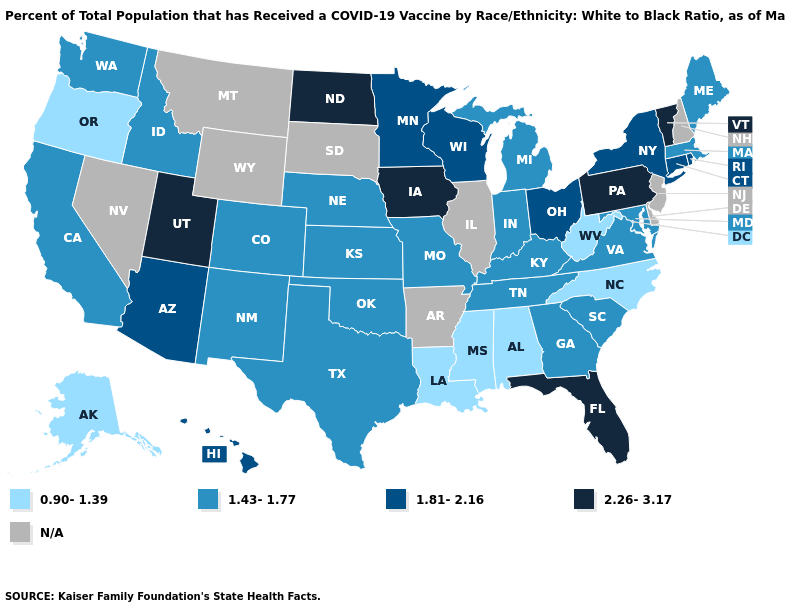Name the states that have a value in the range 2.26-3.17?
Quick response, please. Florida, Iowa, North Dakota, Pennsylvania, Utah, Vermont. What is the value of Georgia?
Concise answer only. 1.43-1.77. Name the states that have a value in the range N/A?
Quick response, please. Arkansas, Delaware, Illinois, Montana, Nevada, New Hampshire, New Jersey, South Dakota, Wyoming. Is the legend a continuous bar?
Concise answer only. No. Name the states that have a value in the range 0.90-1.39?
Answer briefly. Alabama, Alaska, Louisiana, Mississippi, North Carolina, Oregon, West Virginia. Among the states that border Utah , does Colorado have the lowest value?
Short answer required. Yes. Which states have the lowest value in the USA?
Give a very brief answer. Alabama, Alaska, Louisiana, Mississippi, North Carolina, Oregon, West Virginia. Name the states that have a value in the range N/A?
Be succinct. Arkansas, Delaware, Illinois, Montana, Nevada, New Hampshire, New Jersey, South Dakota, Wyoming. What is the value of Montana?
Be succinct. N/A. What is the value of California?
Quick response, please. 1.43-1.77. Which states have the lowest value in the MidWest?
Quick response, please. Indiana, Kansas, Michigan, Missouri, Nebraska. What is the value of Florida?
Short answer required. 2.26-3.17. Name the states that have a value in the range 0.90-1.39?
Keep it brief. Alabama, Alaska, Louisiana, Mississippi, North Carolina, Oregon, West Virginia. Does the first symbol in the legend represent the smallest category?
Be succinct. Yes. What is the lowest value in the West?
Concise answer only. 0.90-1.39. 